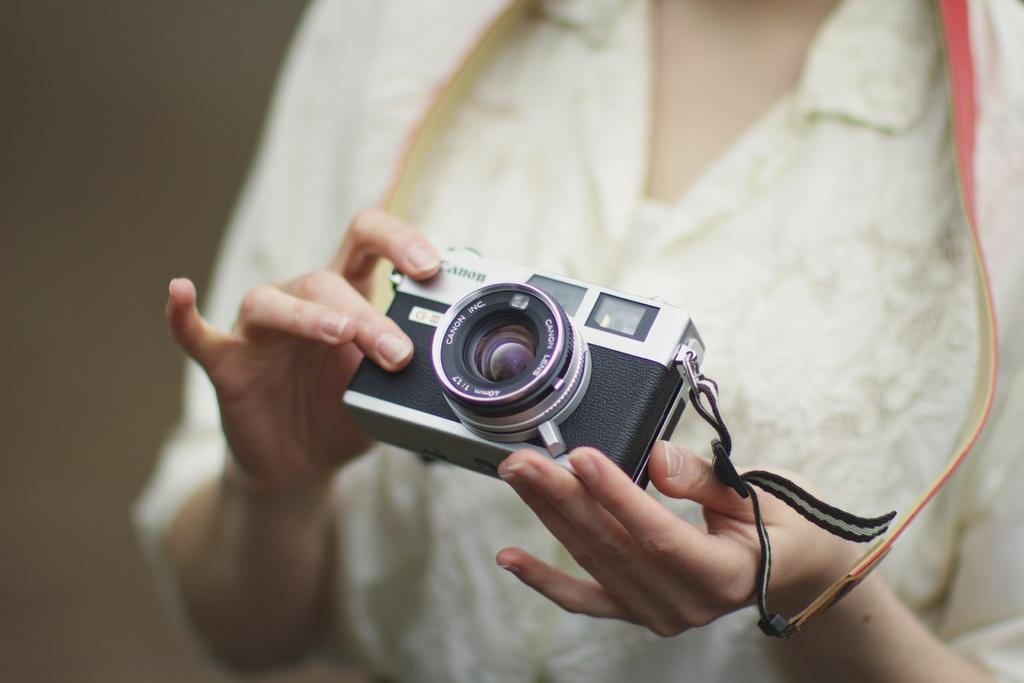Who is the main subject in the image? A: There is a woman in the image. What is the woman wearing? The woman is wearing a white dress. What is the woman holding in the image? The woman is holding a camera. What type of silver landmark can be seen in the background of the image? There is no silver landmark visible in the image; the focus is on the woman and her camera. 